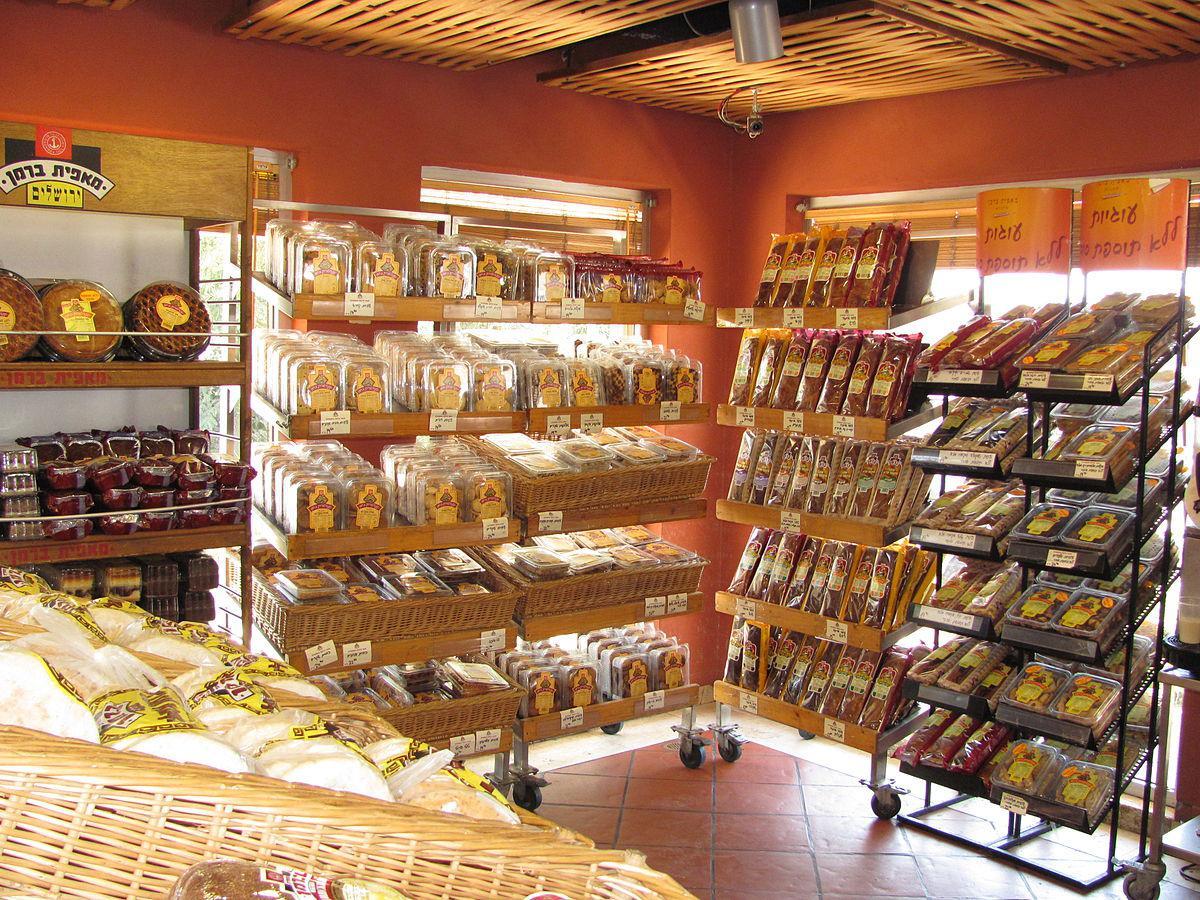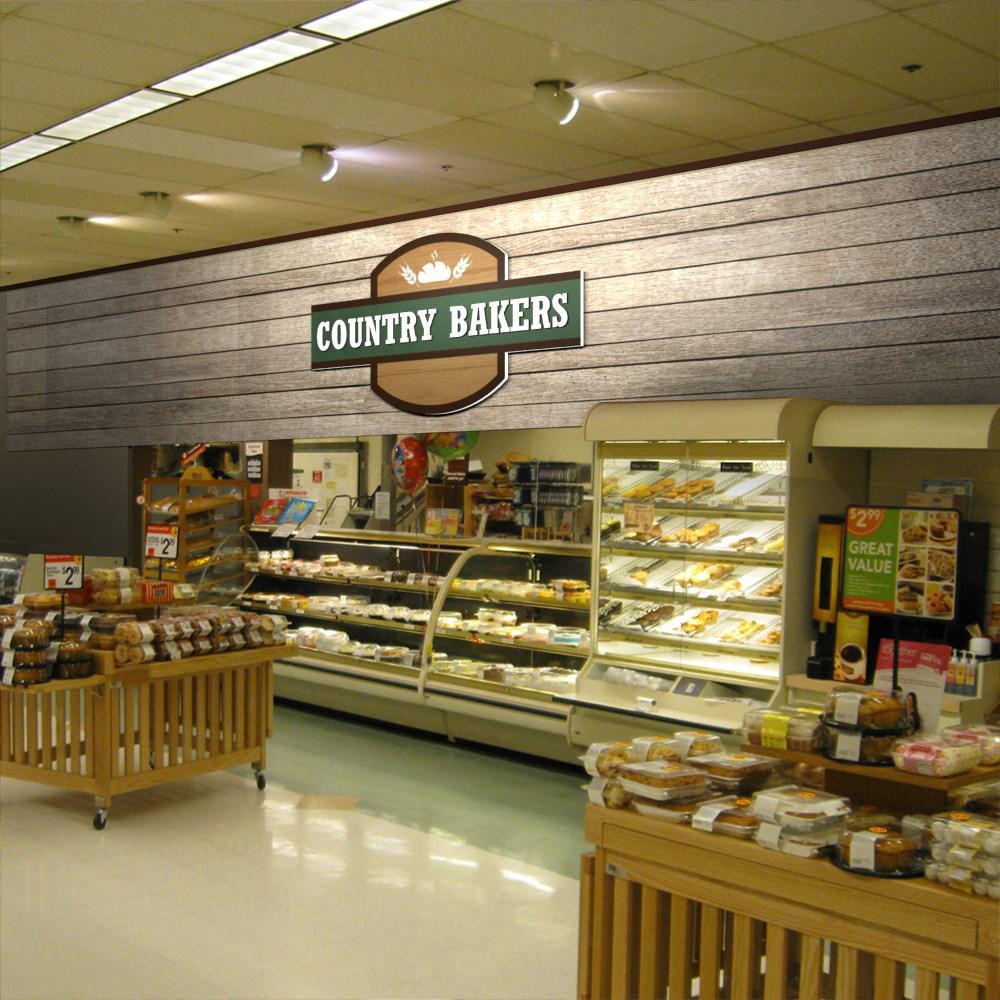The first image is the image on the left, the second image is the image on the right. Assess this claim about the two images: "Bread that is not in any individual packaging is displayed for sale.". Correct or not? Answer yes or no. No. 